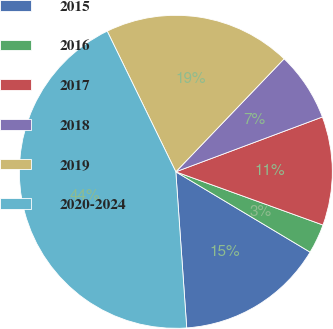Convert chart. <chart><loc_0><loc_0><loc_500><loc_500><pie_chart><fcel>2015<fcel>2016<fcel>2017<fcel>2018<fcel>2019<fcel>2020-2024<nl><fcel>15.31%<fcel>3.06%<fcel>11.22%<fcel>7.14%<fcel>19.39%<fcel>43.89%<nl></chart> 